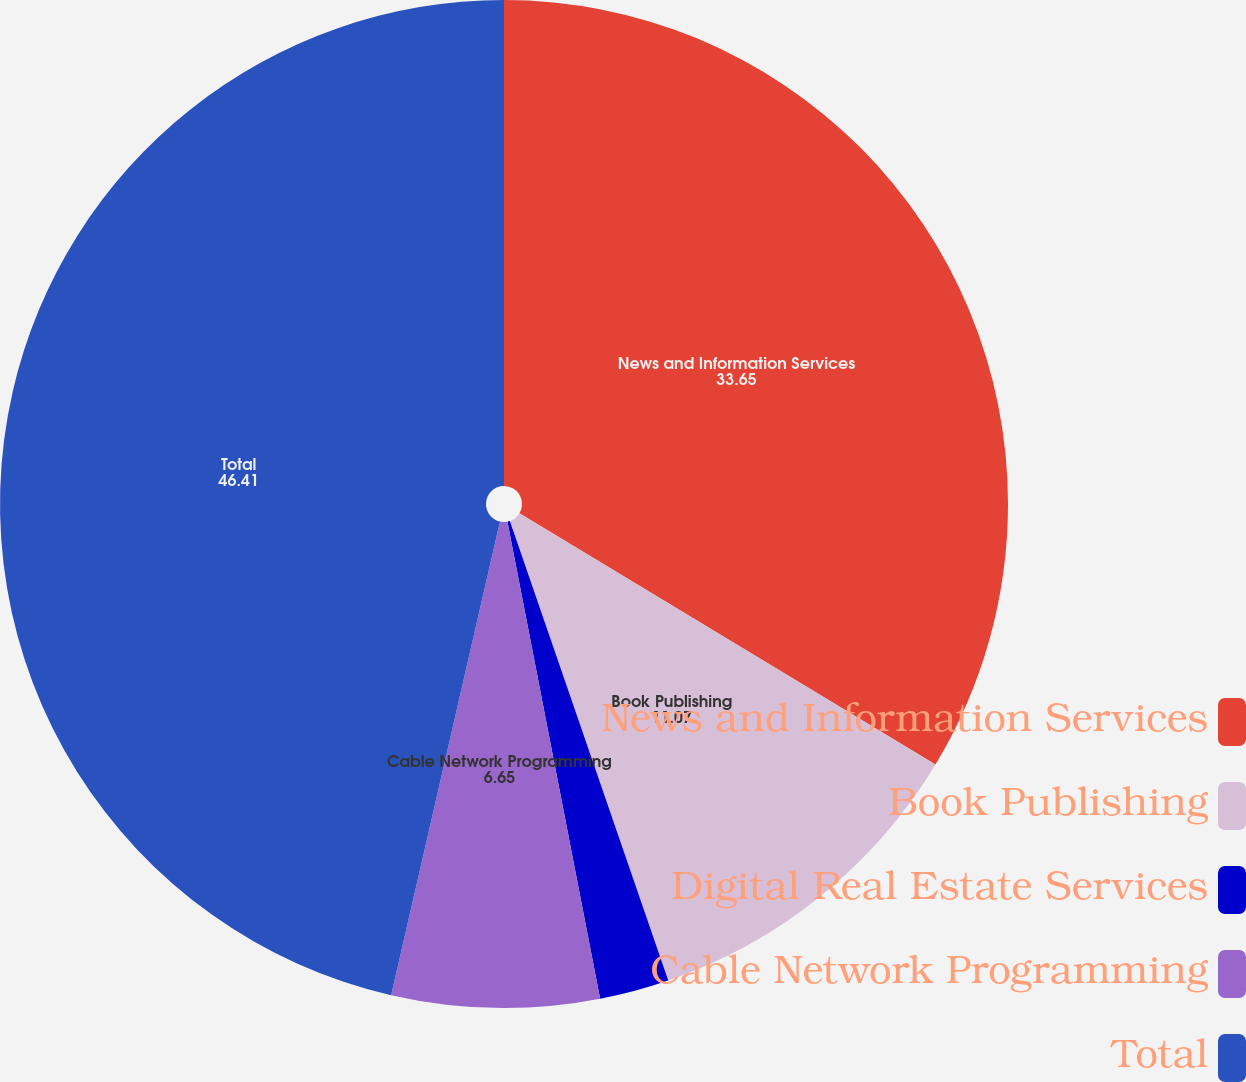Convert chart. <chart><loc_0><loc_0><loc_500><loc_500><pie_chart><fcel>News and Information Services<fcel>Book Publishing<fcel>Digital Real Estate Services<fcel>Cable Network Programming<fcel>Total<nl><fcel>33.65%<fcel>11.07%<fcel>2.23%<fcel>6.65%<fcel>46.41%<nl></chart> 